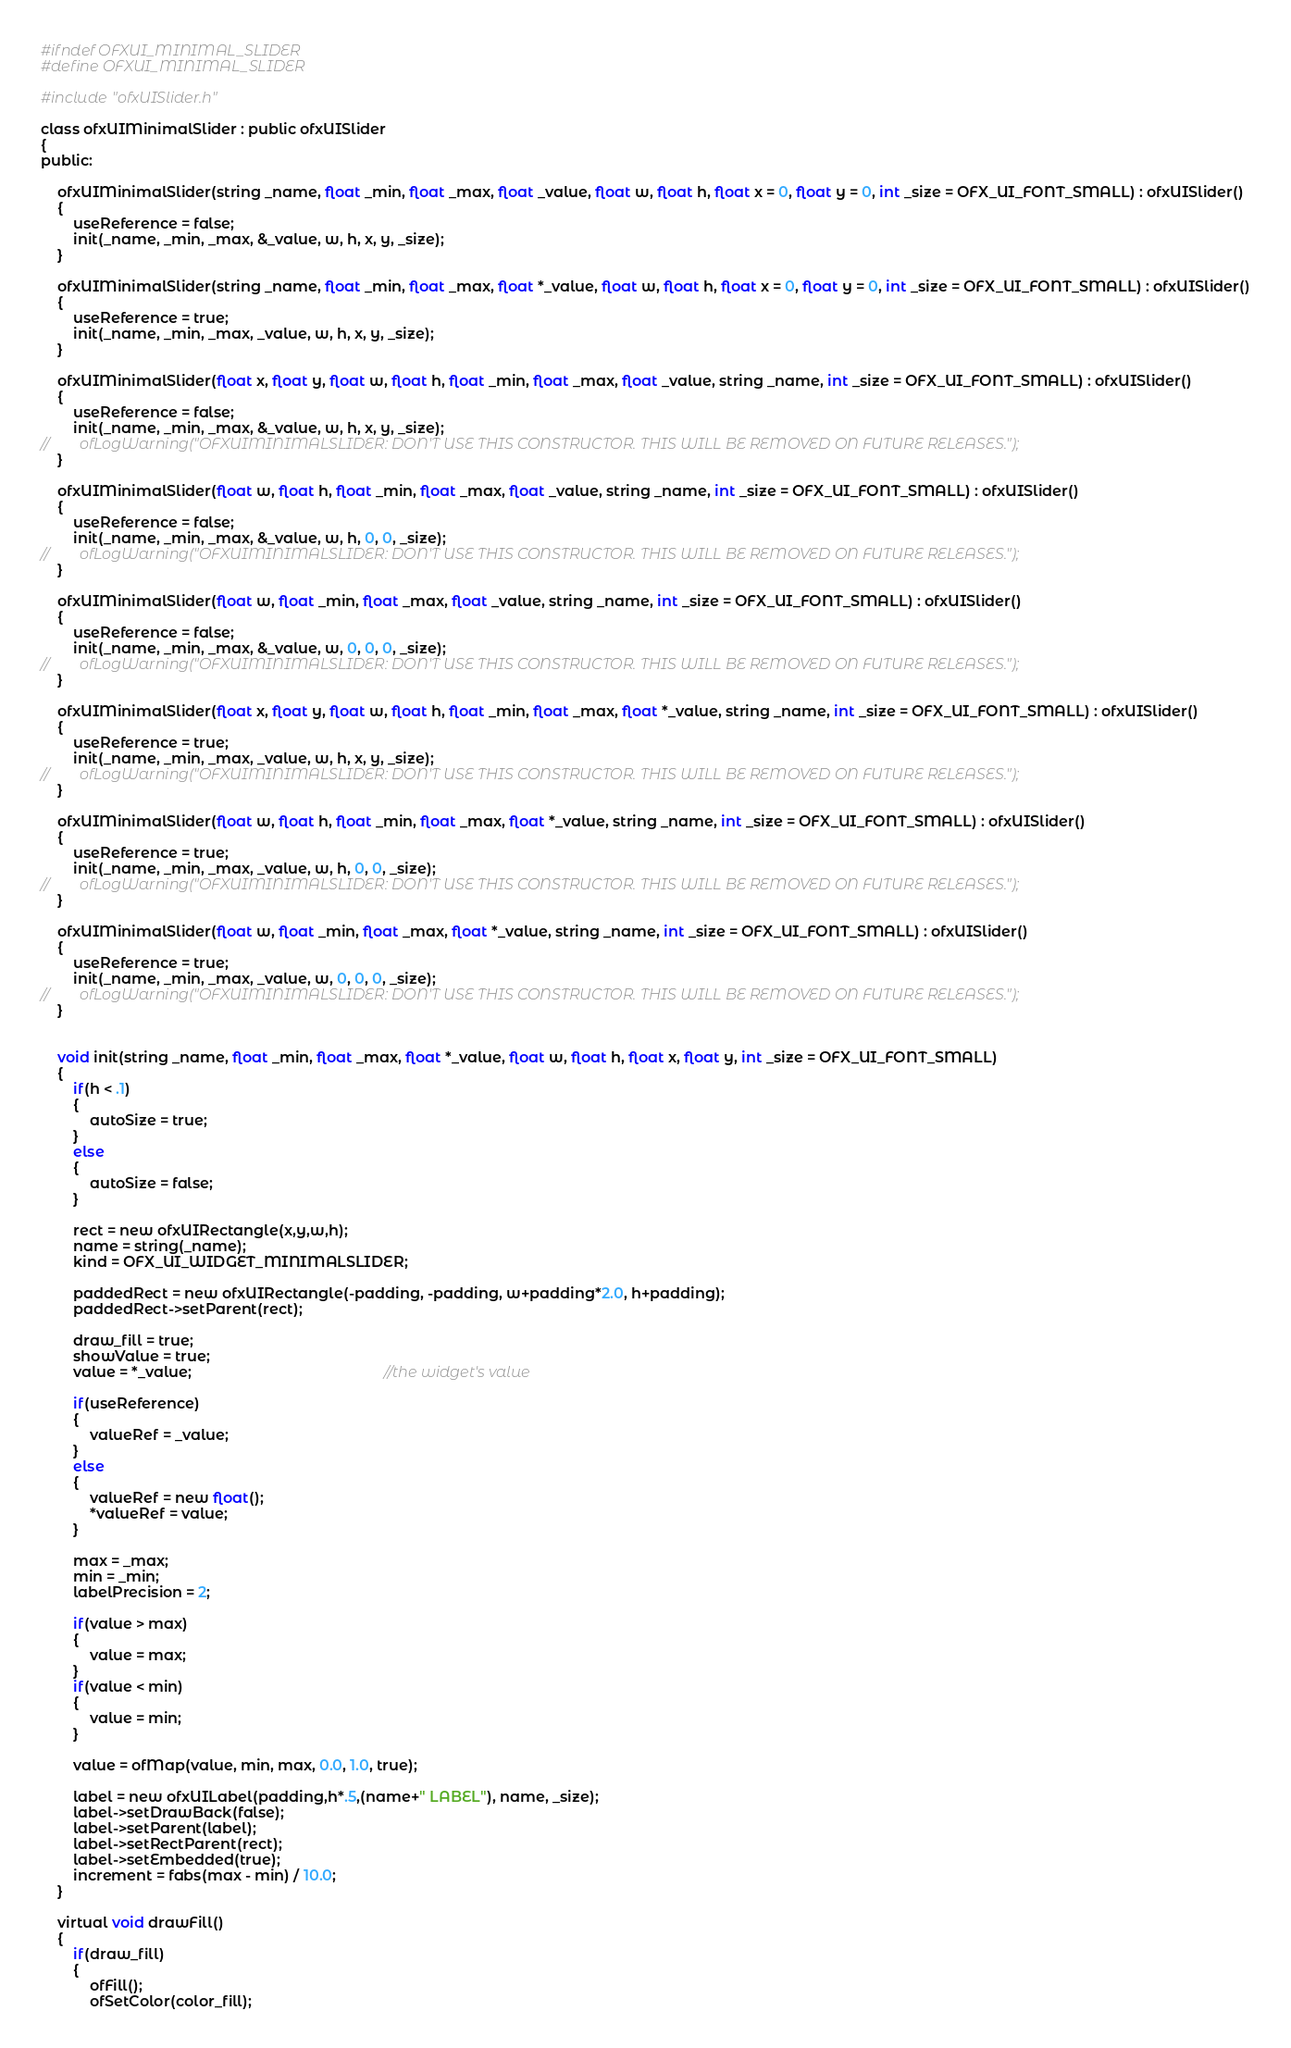Convert code to text. <code><loc_0><loc_0><loc_500><loc_500><_C_>#ifndef OFXUI_MINIMAL_SLIDER
#define OFXUI_MINIMAL_SLIDER

#include "ofxUISlider.h"

class ofxUIMinimalSlider : public ofxUISlider
{
public:
    
    ofxUIMinimalSlider(string _name, float _min, float _max, float _value, float w, float h, float x = 0, float y = 0, int _size = OFX_UI_FONT_SMALL) : ofxUISlider()
    {
        useReference = false;
        init(_name, _min, _max, &_value, w, h, x, y, _size);
    }
    
    ofxUIMinimalSlider(string _name, float _min, float _max, float *_value, float w, float h, float x = 0, float y = 0, int _size = OFX_UI_FONT_SMALL) : ofxUISlider()
    {
        useReference = true;
        init(_name, _min, _max, _value, w, h, x, y, _size);
    }
    
    ofxUIMinimalSlider(float x, float y, float w, float h, float _min, float _max, float _value, string _name, int _size = OFX_UI_FONT_SMALL) : ofxUISlider()
    {
        useReference = false;                                         
        init(_name, _min, _max, &_value, w, h, x, y, _size);
//        ofLogWarning("OFXUIMINIMALSLIDER: DON'T USE THIS CONSTRUCTOR. THIS WILL BE REMOVED ON FUTURE RELEASES.");
    }
    
    ofxUIMinimalSlider(float w, float h, float _min, float _max, float _value, string _name, int _size = OFX_UI_FONT_SMALL) : ofxUISlider()
    {
        useReference = false;                                          
        init(_name, _min, _max, &_value, w, h, 0, 0, _size);
//        ofLogWarning("OFXUIMINIMALSLIDER: DON'T USE THIS CONSTRUCTOR. THIS WILL BE REMOVED ON FUTURE RELEASES.");        
    }
    
    ofxUIMinimalSlider(float w, float _min, float _max, float _value, string _name, int _size = OFX_UI_FONT_SMALL) : ofxUISlider()
    {
        useReference = false;                                                 
        init(_name, _min, _max, &_value, w, 0, 0, 0, _size);
//        ofLogWarning("OFXUIMINIMALSLIDER: DON'T USE THIS CONSTRUCTOR. THIS WILL BE REMOVED ON FUTURE RELEASES.");        
    }
    
    ofxUIMinimalSlider(float x, float y, float w, float h, float _min, float _max, float *_value, string _name, int _size = OFX_UI_FONT_SMALL) : ofxUISlider()
    {
        useReference = true;
        init(_name, _min, _max, _value, w, h, x, y, _size);
//        ofLogWarning("OFXUIMINIMALSLIDER: DON'T USE THIS CONSTRUCTOR. THIS WILL BE REMOVED ON FUTURE RELEASES.");        
    }
    
    ofxUIMinimalSlider(float w, float h, float _min, float _max, float *_value, string _name, int _size = OFX_UI_FONT_SMALL) : ofxUISlider()
    {
        useReference = true;
        init(_name, _min, _max, _value, w, h, 0, 0, _size);
//        ofLogWarning("OFXUIMINIMALSLIDER: DON'T USE THIS CONSTRUCTOR. THIS WILL BE REMOVED ON FUTURE RELEASES.");        
    }
    
    ofxUIMinimalSlider(float w, float _min, float _max, float *_value, string _name, int _size = OFX_UI_FONT_SMALL) : ofxUISlider()
    {
        useReference = true;                                                 
        init(_name, _min, _max, _value, w, 0, 0, 0, _size);
//        ofLogWarning("OFXUIMINIMALSLIDER: DON'T USE THIS CONSTRUCTOR. THIS WILL BE REMOVED ON FUTURE RELEASES.");        
    }
    

    void init(string _name, float _min, float _max, float *_value, float w, float h, float x, float y, int _size = OFX_UI_FONT_SMALL) 
    {
        if(h < .1)
        {
            autoSize = true;
        }
        else
        {
            autoSize = false; 
        }
        
        rect = new ofxUIRectangle(x,y,w,h);
        name = string(_name);  				
        kind = OFX_UI_WIDGET_MINIMALSLIDER;
        
		paddedRect = new ofxUIRectangle(-padding, -padding, w+padding*2.0, h+padding);
		paddedRect->setParent(rect);     
        
        draw_fill = true; 
        showValue = true; 
        value = *_value;                                               //the widget's value
        
        if(useReference)
        {
            valueRef = _value; 
        }
        else
        {
            valueRef = new float(); 
            *valueRef = value; 
        }
        
		max = _max; 
		min = _min; 
        labelPrecision = 2;
        
		if(value > max)
		{
			value = max; 
		}
		if(value < min)
		{
			value = min; 
		}
		
		value = ofMap(value, min, max, 0.0, 1.0, true); 
        
        label = new ofxUILabel(padding,h*.5,(name+" LABEL"), name, _size); 	
        label->setDrawBack(false);
		label->setParent(label); 
		label->setRectParent(rect); 	
        label->setEmbedded(true);        
        increment = fabs(max - min) / 10.0;
    }
    
    virtual void drawFill()
    {
        if(draw_fill)
        {			
            ofFill(); 
            ofSetColor(color_fill); </code> 